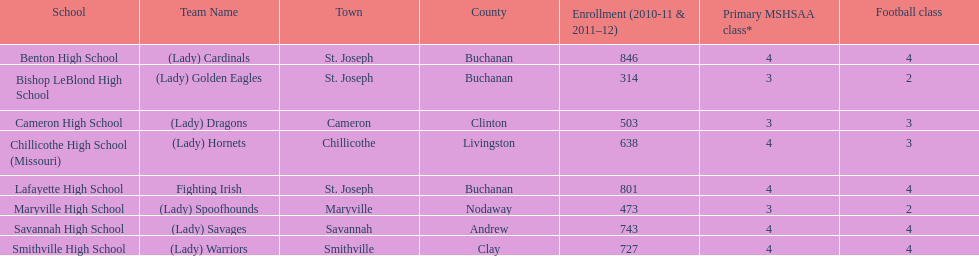Would you be able to parse every entry in this table? {'header': ['School', 'Team Name', 'Town', 'County', 'Enrollment (2010-11 & 2011–12)', 'Primary MSHSAA class*', 'Football class'], 'rows': [['Benton High School', '(Lady) Cardinals', 'St. Joseph', 'Buchanan', '846', '4', '4'], ['Bishop LeBlond High School', '(Lady) Golden Eagles', 'St. Joseph', 'Buchanan', '314', '3', '2'], ['Cameron High School', '(Lady) Dragons', 'Cameron', 'Clinton', '503', '3', '3'], ['Chillicothe High School (Missouri)', '(Lady) Hornets', 'Chillicothe', 'Livingston', '638', '4', '3'], ['Lafayette High School', 'Fighting Irish', 'St. Joseph', 'Buchanan', '801', '4', '4'], ['Maryville High School', '(Lady) Spoofhounds', 'Maryville', 'Nodaway', '473', '3', '2'], ['Savannah High School', '(Lady) Savages', 'Savannah', 'Andrew', '743', '4', '4'], ['Smithville High School', '(Lady) Warriors', 'Smithville', 'Clay', '727', '4', '4']]} What is the number of football classes lafayette high school has? 4. 